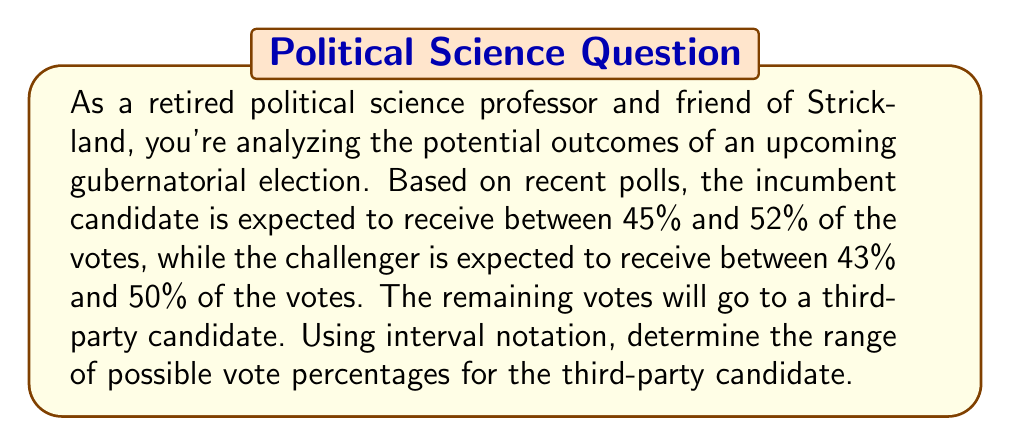Show me your answer to this math problem. Let's approach this step-by-step:

1) Let $x$ be the percentage of votes for the third-party candidate.

2) We know that the total percentage of votes must sum to 100%:

   Incumbent + Challenger + Third-party = 100%

3) Using the given ranges, we can express this as an inequality:

   $45\% \leq \text{Incumbent} \leq 52\%$
   $43\% \leq \text{Challenger} \leq 50\%$
   $x = \text{Third-party}$

4) To find the minimum possible value for $x$, we consider the maximum values for the incumbent and challenger:

   $52\% + 50\% + x_{min} = 100\%$
   $x_{min} = 100\% - 52\% - 50\% = -2\%$

5) However, since vote percentages can't be negative, the actual minimum for $x$ is 0%:

   $x_{min} = 0\%$

6) To find the maximum possible value for $x$, we consider the minimum values for the incumbent and challenger:

   $45\% + 43\% + x_{max} = 100\%$
   $x_{max} = 100\% - 45\% - 43\% = 12\%$

7) Therefore, the range of possible vote percentages for the third-party candidate is $[0\%, 12\%]$ in interval notation.
Answer: $[0, 12]$ 